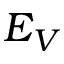<formula> <loc_0><loc_0><loc_500><loc_500>E _ { V }</formula> 